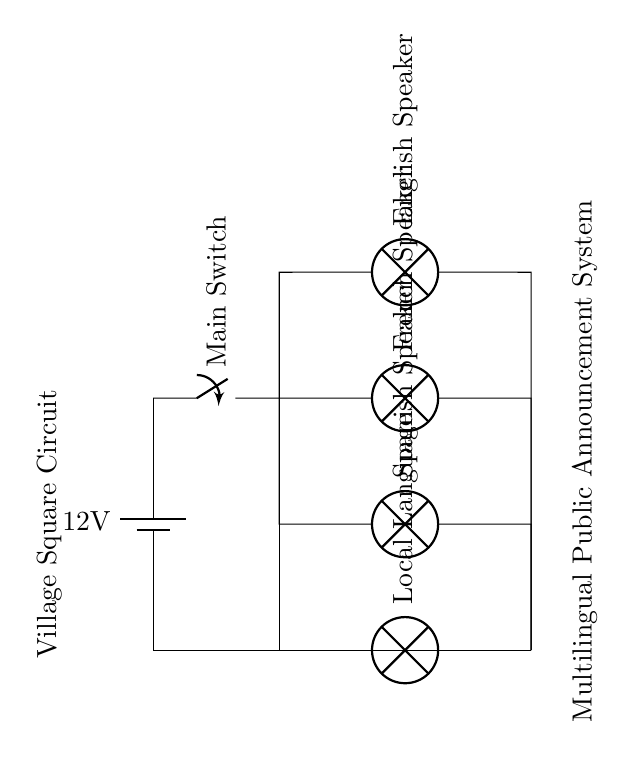What is the voltage of this circuit? The voltage is 12 volts, which is indicated next to the battery symbol.
Answer: 12 volts What components are connected in parallel? The components connected in parallel are the English Speaker, French Speaker, Spanish Speaker, and Local Language. They are all connected to the same supply line from the main switch pointing toward the ground.
Answer: English Speaker, French Speaker, Spanish Speaker, Local Language What is the purpose of the main switch? The main switch controls the entire circuit's power supply, allowing or cutting off electricity to all connected speakers at once.
Answer: Power control How many speakers are present in the circuit? There are four speakers in total, one for each language, connected parallelly, allowing them to operate independently of each other.
Answer: Four speakers If one speaker fails, what happens to the others? If one speaker fails, the others will continue to function because they are in a parallel configuration, which allows electricity to flow to the remaining speakers independently.
Answer: They continue to function What happens to the total resistance if one more speaker is added? The total resistance would decrease because adding another parallel branch reduces overall resistance, following the formula for parallel resistances.
Answer: Decreases 